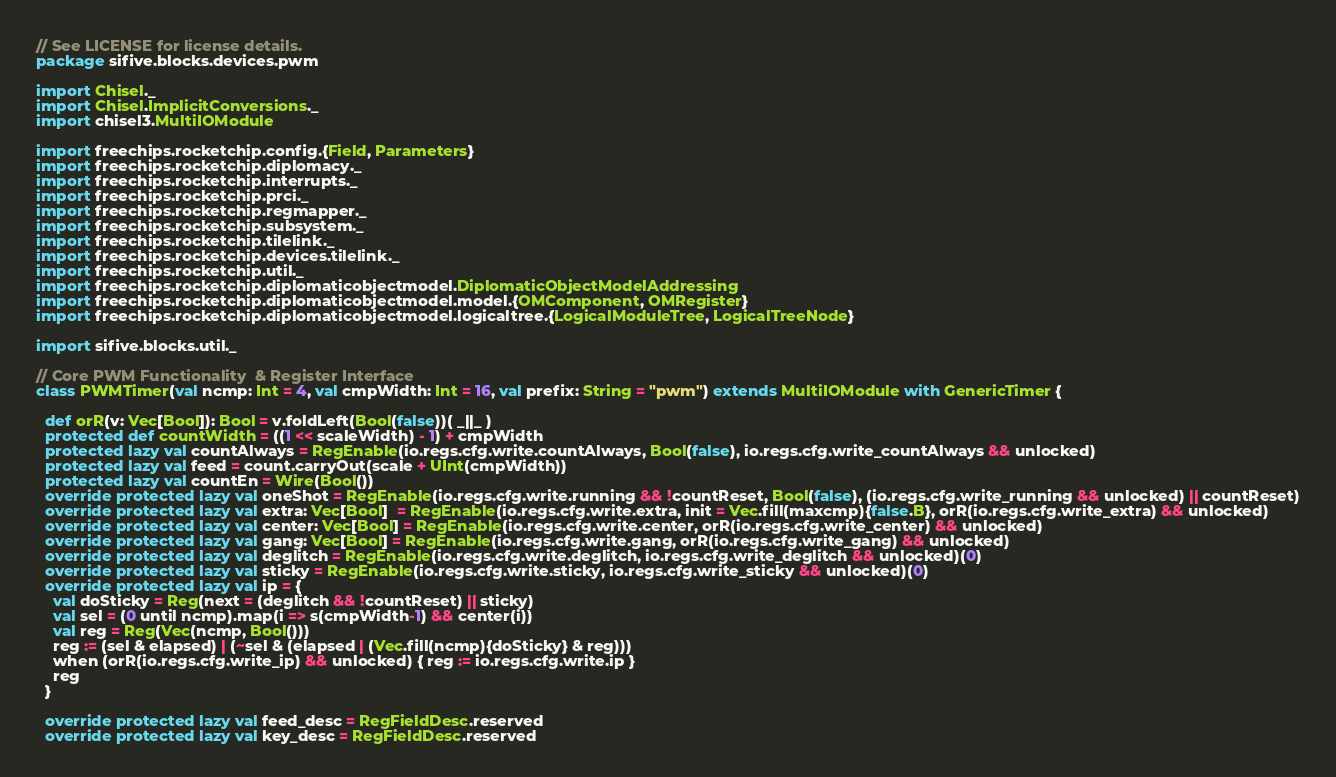<code> <loc_0><loc_0><loc_500><loc_500><_Scala_>// See LICENSE for license details.
package sifive.blocks.devices.pwm

import Chisel._
import Chisel.ImplicitConversions._
import chisel3.MultiIOModule

import freechips.rocketchip.config.{Field, Parameters}
import freechips.rocketchip.diplomacy._
import freechips.rocketchip.interrupts._
import freechips.rocketchip.prci._
import freechips.rocketchip.regmapper._
import freechips.rocketchip.subsystem._
import freechips.rocketchip.tilelink._
import freechips.rocketchip.devices.tilelink._
import freechips.rocketchip.util._
import freechips.rocketchip.diplomaticobjectmodel.DiplomaticObjectModelAddressing
import freechips.rocketchip.diplomaticobjectmodel.model.{OMComponent, OMRegister}
import freechips.rocketchip.diplomaticobjectmodel.logicaltree.{LogicalModuleTree, LogicalTreeNode}

import sifive.blocks.util._

// Core PWM Functionality  & Register Interface
class PWMTimer(val ncmp: Int = 4, val cmpWidth: Int = 16, val prefix: String = "pwm") extends MultiIOModule with GenericTimer {

  def orR(v: Vec[Bool]): Bool = v.foldLeft(Bool(false))( _||_ )
  protected def countWidth = ((1 << scaleWidth) - 1) + cmpWidth
  protected lazy val countAlways = RegEnable(io.regs.cfg.write.countAlways, Bool(false), io.regs.cfg.write_countAlways && unlocked)
  protected lazy val feed = count.carryOut(scale + UInt(cmpWidth))
  protected lazy val countEn = Wire(Bool())
  override protected lazy val oneShot = RegEnable(io.regs.cfg.write.running && !countReset, Bool(false), (io.regs.cfg.write_running && unlocked) || countReset)
  override protected lazy val extra: Vec[Bool]  = RegEnable(io.regs.cfg.write.extra, init = Vec.fill(maxcmp){false.B}, orR(io.regs.cfg.write_extra) && unlocked)
  override protected lazy val center: Vec[Bool] = RegEnable(io.regs.cfg.write.center, orR(io.regs.cfg.write_center) && unlocked)
  override protected lazy val gang: Vec[Bool] = RegEnable(io.regs.cfg.write.gang, orR(io.regs.cfg.write_gang) && unlocked)
  override protected lazy val deglitch = RegEnable(io.regs.cfg.write.deglitch, io.regs.cfg.write_deglitch && unlocked)(0)
  override protected lazy val sticky = RegEnable(io.regs.cfg.write.sticky, io.regs.cfg.write_sticky && unlocked)(0)
  override protected lazy val ip = {
    val doSticky = Reg(next = (deglitch && !countReset) || sticky)
    val sel = (0 until ncmp).map(i => s(cmpWidth-1) && center(i))
    val reg = Reg(Vec(ncmp, Bool()))
    reg := (sel & elapsed) | (~sel & (elapsed | (Vec.fill(ncmp){doSticky} & reg)))
    when (orR(io.regs.cfg.write_ip) && unlocked) { reg := io.regs.cfg.write.ip }
    reg
  }

  override protected lazy val feed_desc = RegFieldDesc.reserved
  override protected lazy val key_desc = RegFieldDesc.reserved</code> 